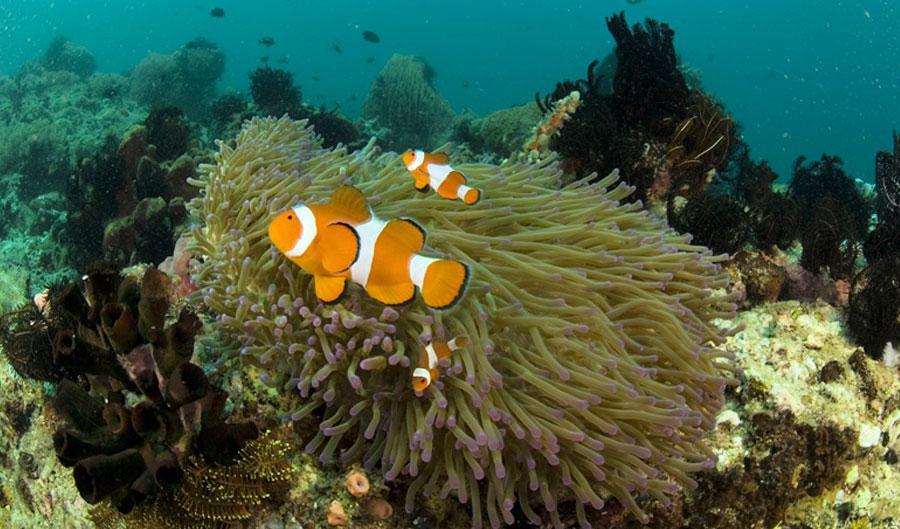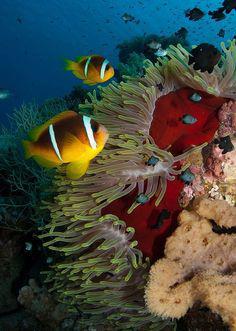The first image is the image on the left, the second image is the image on the right. Analyze the images presented: Is the assertion "The right image features at least one clown fish swimming in front of anemone tendrils, and the left image includes at least one anemone with tapering tendrils and an orange stalk." valid? Answer yes or no. No. The first image is the image on the left, the second image is the image on the right. Given the left and right images, does the statement "The right image contains at least two clown fish." hold true? Answer yes or no. Yes. 